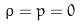Convert formula to latex. <formula><loc_0><loc_0><loc_500><loc_500>\rho = p = 0</formula> 